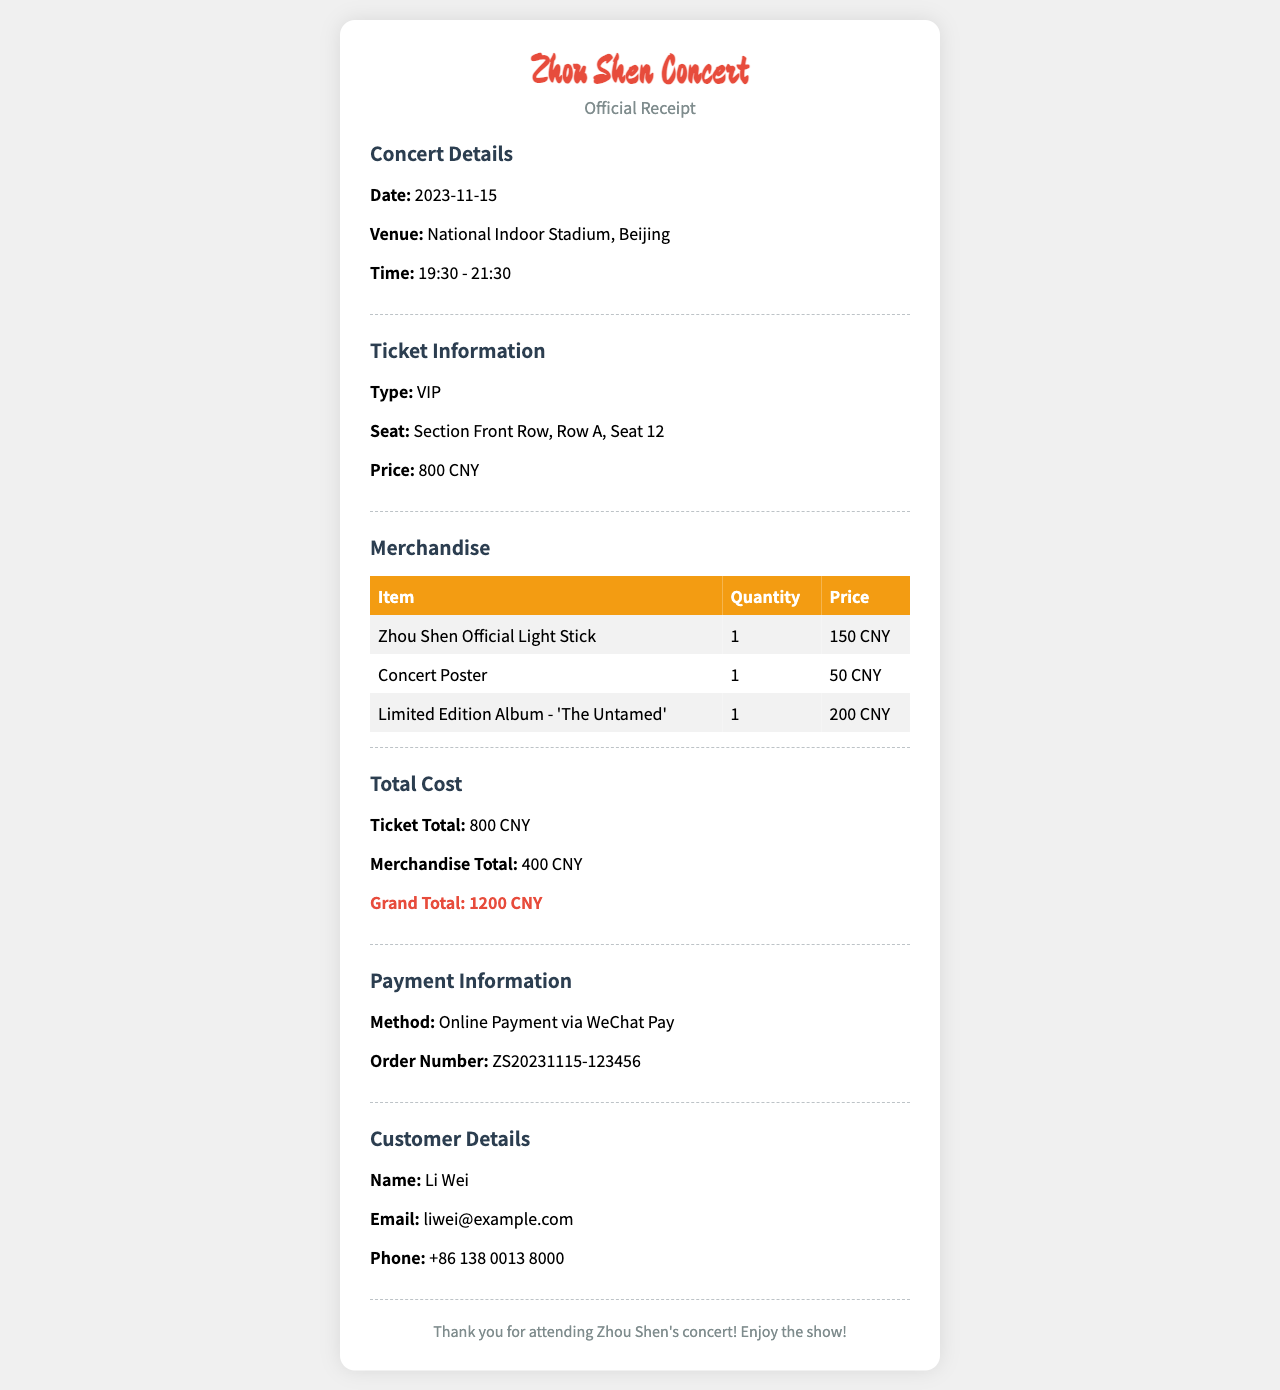What is the date of the concert? The concert is scheduled for November 15, 2023.
Answer: November 15, 2023 What type of ticket was purchased? The ticket type listed in the document is VIP.
Answer: VIP How much was the ticket price? The document specifies that the ticket price is 800 CNY.
Answer: 800 CNY What is the total cost of merchandise? The total cost of merchandise is calculated by adding the prices of three items listed.
Answer: 400 CNY What item is the limited edition album? According to the merchandise section, the limited edition album is 'The Untamed'.
Answer: 'The Untamed' How many items were purchased in total? The merchandise includes three separate items listed in the table.
Answer: 3 What is the order number for the payment? The order number is mentioned in the payment information section.
Answer: ZS20231115-123456 What payment method was used? The document states that the payment was made via WeChat Pay.
Answer: WeChat Pay What is the name of the customer? The customer's name is provided in the customer details section of the receipt.
Answer: Li Wei 